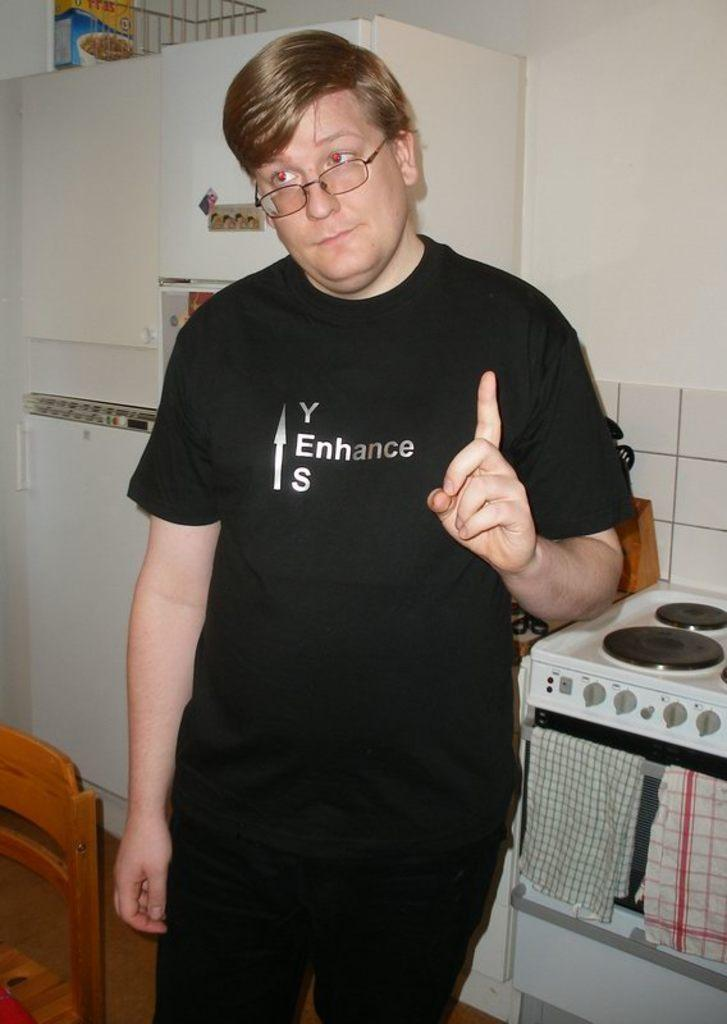Provide a one-sentence caption for the provided image. A man stands in a kitchen with a shirt that has the word enhance on it. 